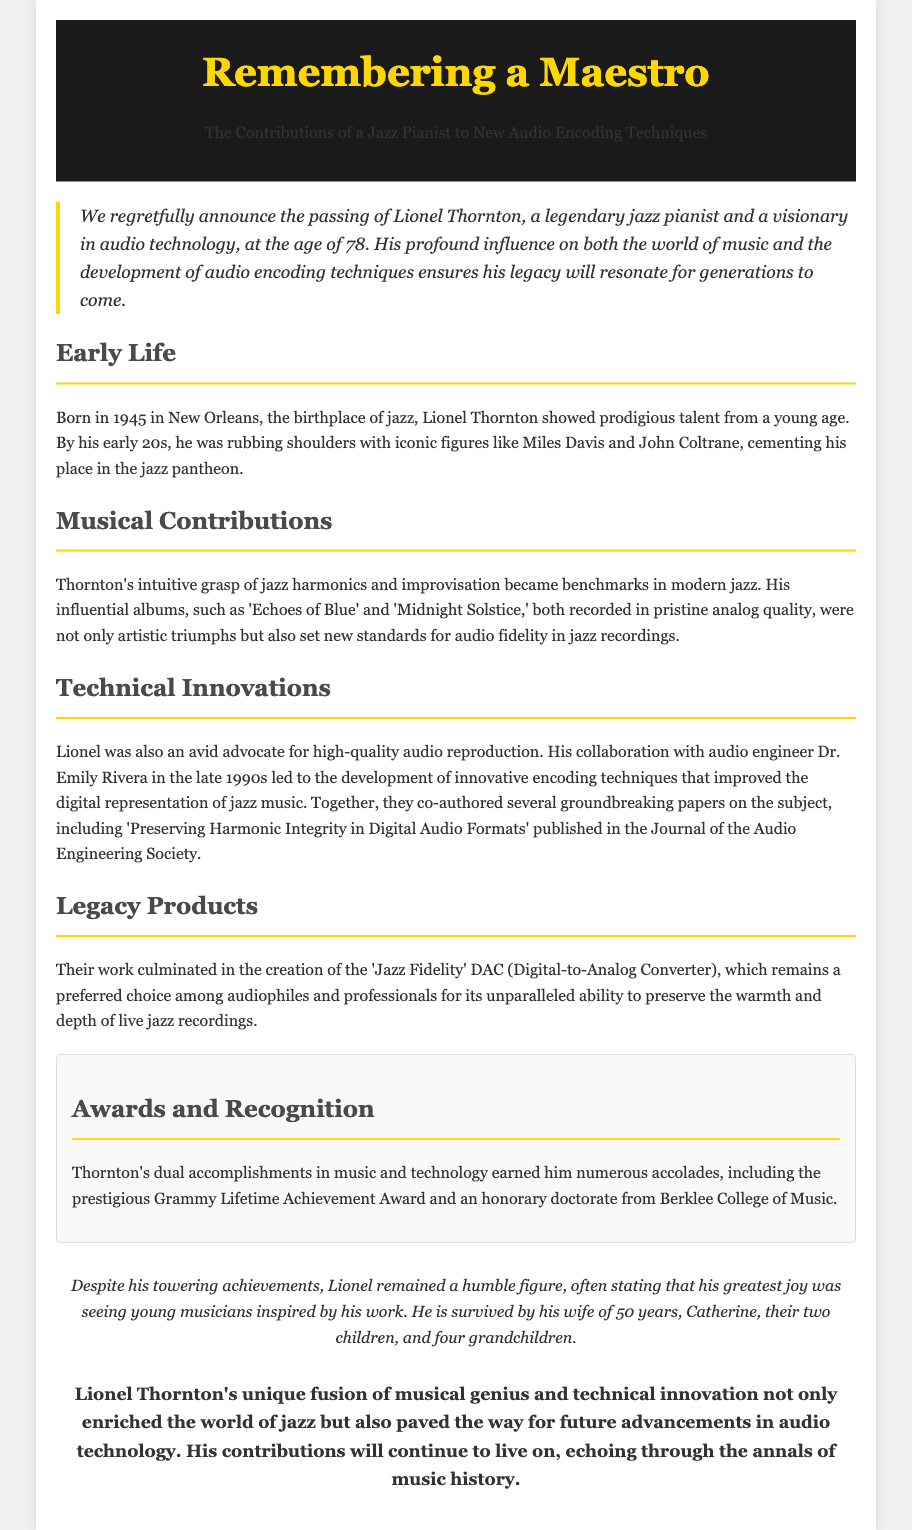What was Lionel Thornton's age at passing? The document states that Lionel Thornton passed away at the age of 78.
Answer: 78 In which city was Lionel Thornton born? The document mentions that he was born in New Orleans, the birthplace of jazz.
Answer: New Orleans What is the title of one of Lionel Thornton's influential albums? The document references his albums, including 'Echoes of Blue' and 'Midnight Solstice.'
Answer: Echoes of Blue What did Lionel Thornton co-author with Dr. Emily Rivera? The document indicates that he co-authored several groundbreaking papers on audio encoding techniques.
Answer: Groundbreaking papers Which award did Lionel Thornton receive for his music and technology contributions? The document lists the prestigious Grammy Lifetime Achievement Award among his accolades.
Answer: Grammy Lifetime Achievement Award What was the name of the Digital-to-Analog Converter they created? The document describes the creation of the 'Jazz Fidelity' DAC.
Answer: Jazz Fidelity What was Lionel Thornton's greatest joy according to the document? The document mentions that his greatest joy was seeing young musicians inspired by his work.
Answer: Young musicians inspired What significant collaboration did Thornton have in the late 1990s? The document states that he collaborated with audio engineer Dr. Emily Rivera to develop innovative encoding techniques.
Answer: Innovative encoding techniques 